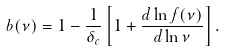Convert formula to latex. <formula><loc_0><loc_0><loc_500><loc_500>b ( \nu ) = 1 - \frac { 1 } { \delta _ { c } } \left [ 1 + \frac { d \ln f ( \nu ) } { d \ln \nu } \right ] .</formula> 